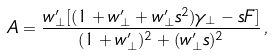<formula> <loc_0><loc_0><loc_500><loc_500>A = \frac { w _ { \perp } ^ { \prime } [ ( 1 + w _ { \perp } ^ { \prime } + w _ { \perp } ^ { \prime } s ^ { 2 } ) \gamma _ { \perp } - s F ] } { ( 1 + w _ { \perp } ^ { \prime } ) ^ { 2 } + ( w _ { \perp } ^ { \prime } s ) ^ { 2 } } \, ,</formula> 